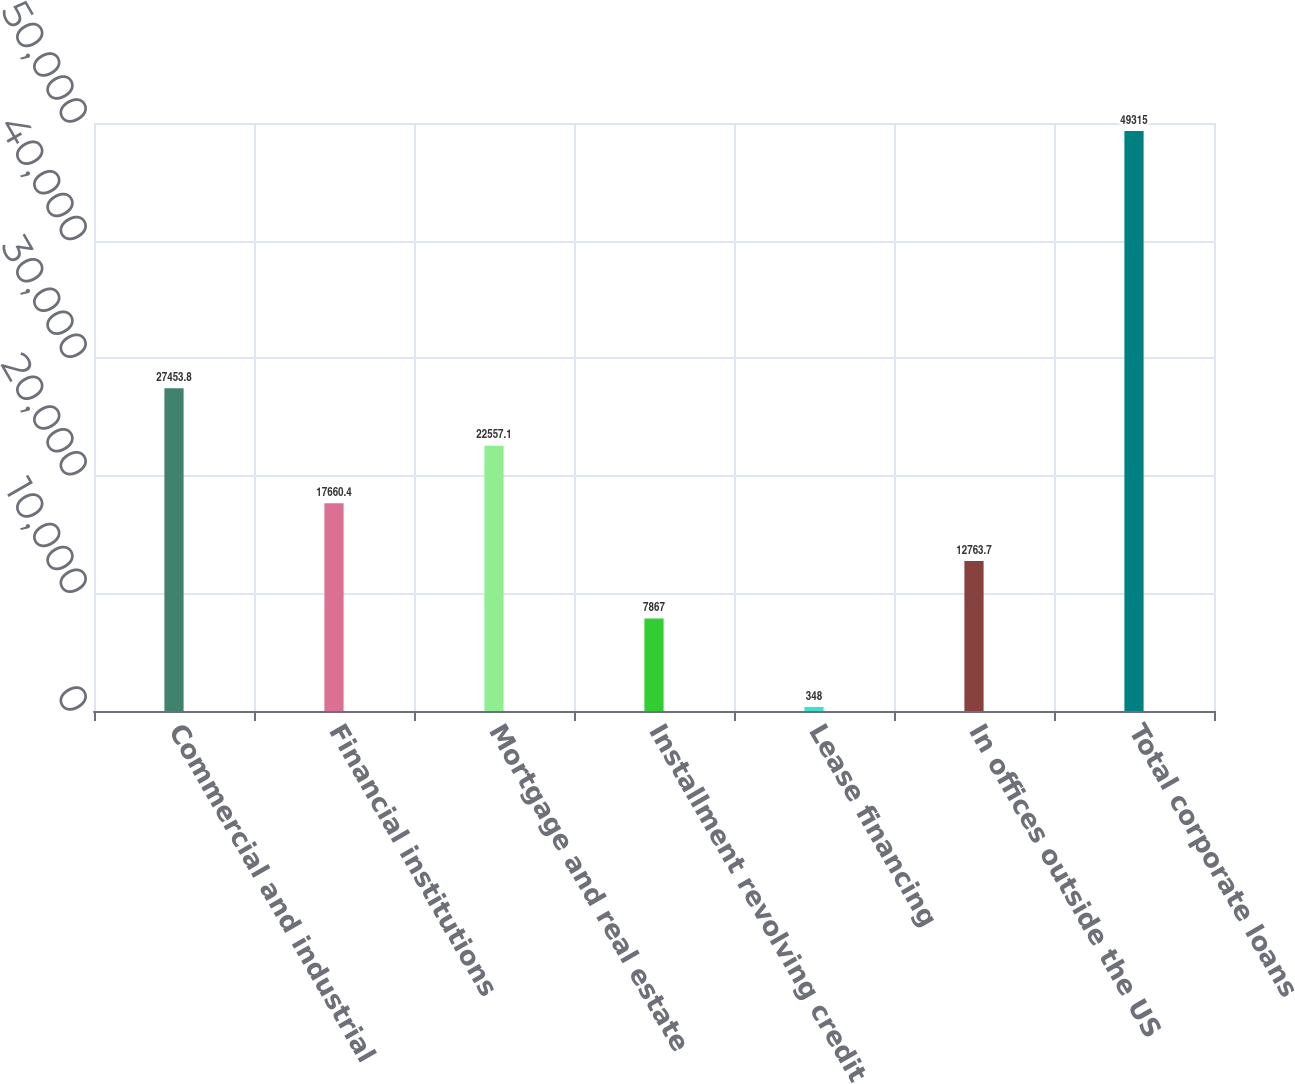Convert chart to OTSL. <chart><loc_0><loc_0><loc_500><loc_500><bar_chart><fcel>Commercial and industrial<fcel>Financial institutions<fcel>Mortgage and real estate<fcel>Installment revolving credit<fcel>Lease financing<fcel>In offices outside the US<fcel>Total corporate loans<nl><fcel>27453.8<fcel>17660.4<fcel>22557.1<fcel>7867<fcel>348<fcel>12763.7<fcel>49315<nl></chart> 